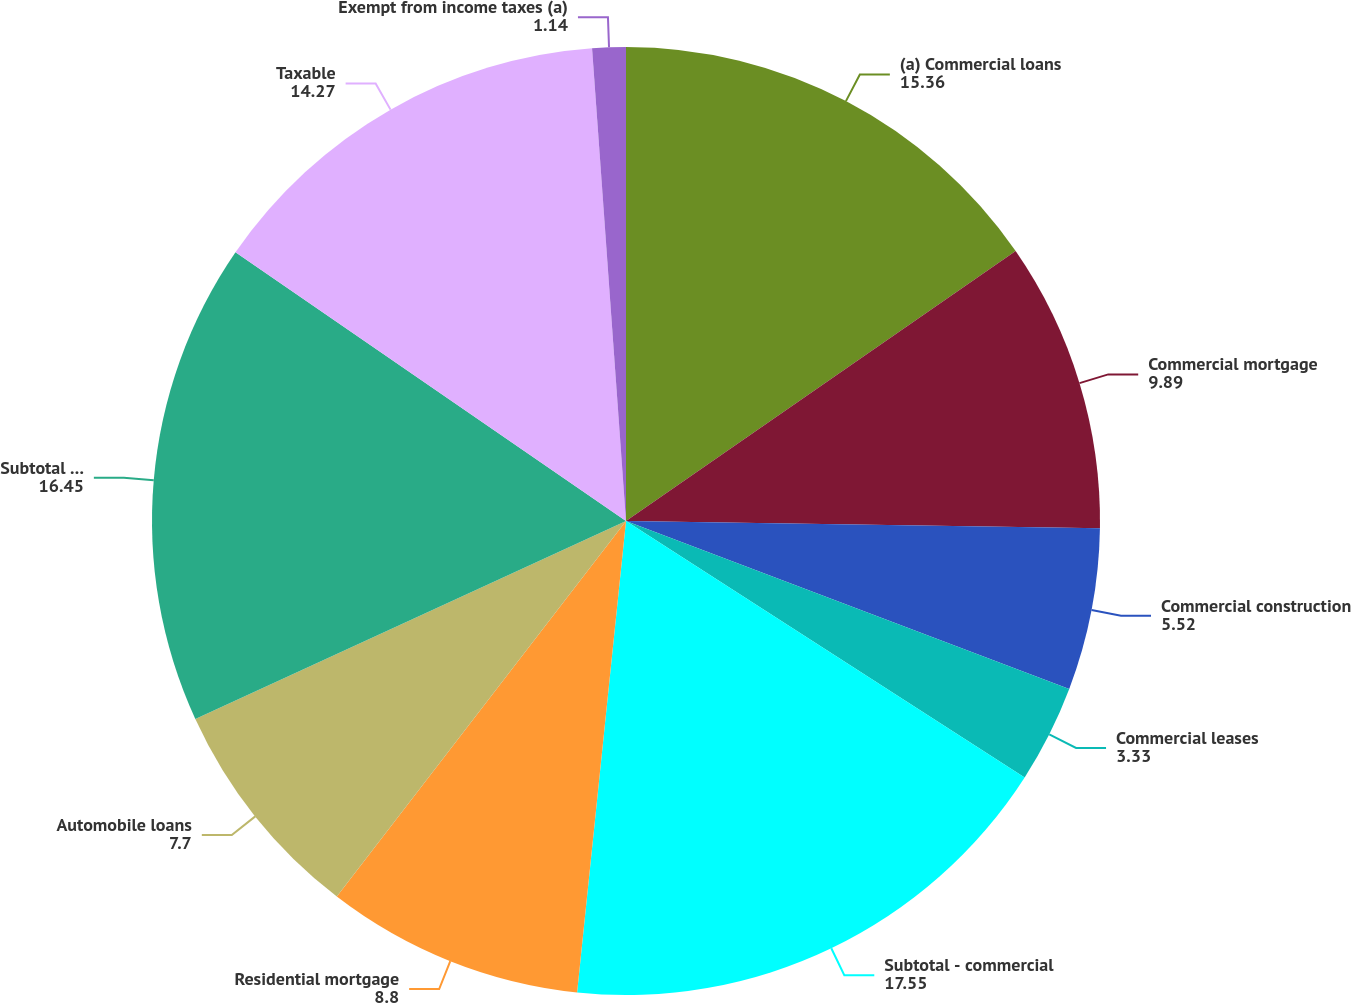Convert chart to OTSL. <chart><loc_0><loc_0><loc_500><loc_500><pie_chart><fcel>(a) Commercial loans<fcel>Commercial mortgage<fcel>Commercial construction<fcel>Commercial leases<fcel>Subtotal - commercial<fcel>Residential mortgage<fcel>Automobile loans<fcel>Subtotal - consumer<fcel>Taxable<fcel>Exempt from income taxes (a)<nl><fcel>15.36%<fcel>9.89%<fcel>5.52%<fcel>3.33%<fcel>17.55%<fcel>8.8%<fcel>7.7%<fcel>16.45%<fcel>14.27%<fcel>1.14%<nl></chart> 